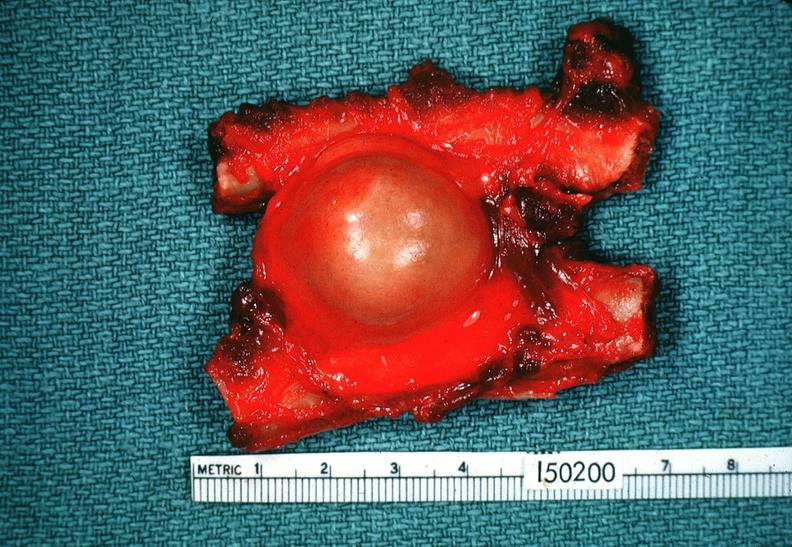s nervous present?
Answer the question using a single word or phrase. Yes 